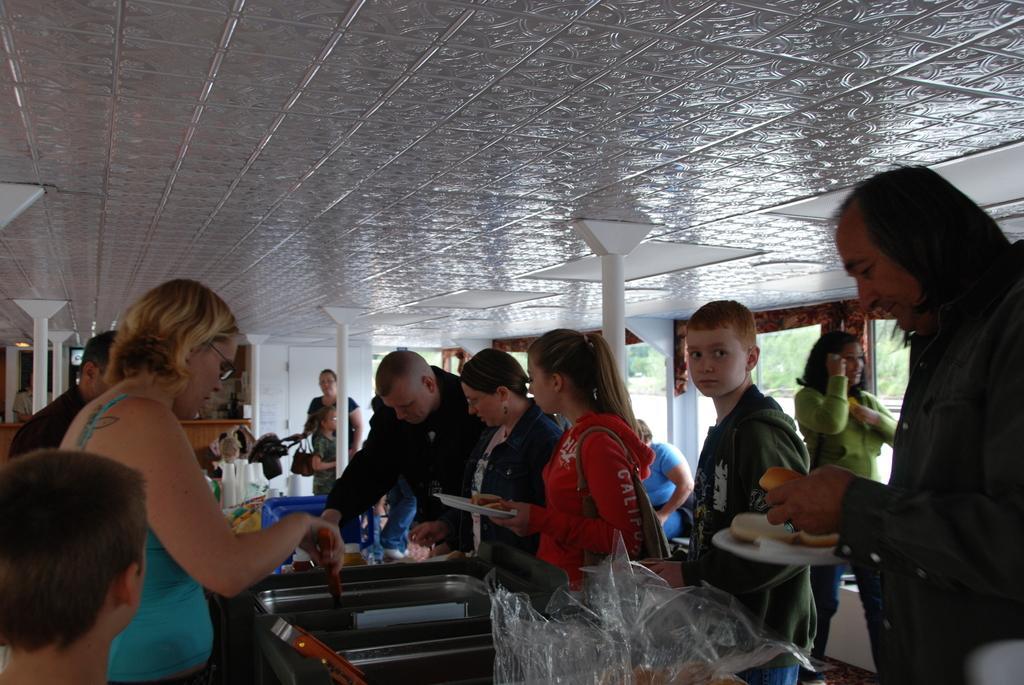In one or two sentences, can you explain what this image depicts? In this image, we can see persons wearing clothes. There is a dish and plastic cover in the middle of the image. There are pillars on the left and in the middle of the image. There is a ceiling at the top of the image. 